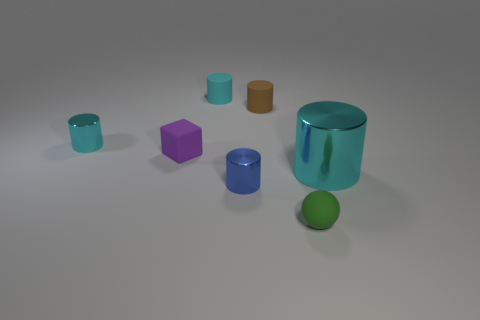There is a tiny cylinder in front of the big metal object; what material is it?
Provide a succinct answer. Metal. There is a tiny thing on the right side of the tiny brown cylinder; what number of objects are behind it?
Ensure brevity in your answer.  6. Is there a small object that has the same shape as the large metal object?
Give a very brief answer. Yes. Is the size of the shiny cylinder left of the cyan matte thing the same as the rubber cylinder that is right of the tiny blue metallic object?
Make the answer very short. Yes. What shape is the rubber thing in front of the cyan metallic cylinder that is in front of the tiny cyan metal cylinder?
Your answer should be compact. Sphere. What number of cylinders have the same size as the rubber ball?
Your answer should be compact. 4. Is there a green matte ball?
Provide a succinct answer. Yes. Is there anything else of the same color as the matte ball?
Provide a short and direct response. No. What is the shape of the brown thing that is made of the same material as the tiny block?
Provide a short and direct response. Cylinder. What is the color of the large metallic thing that is to the right of the cyan cylinder that is behind the cyan metallic object that is to the left of the blue object?
Offer a terse response. Cyan. 